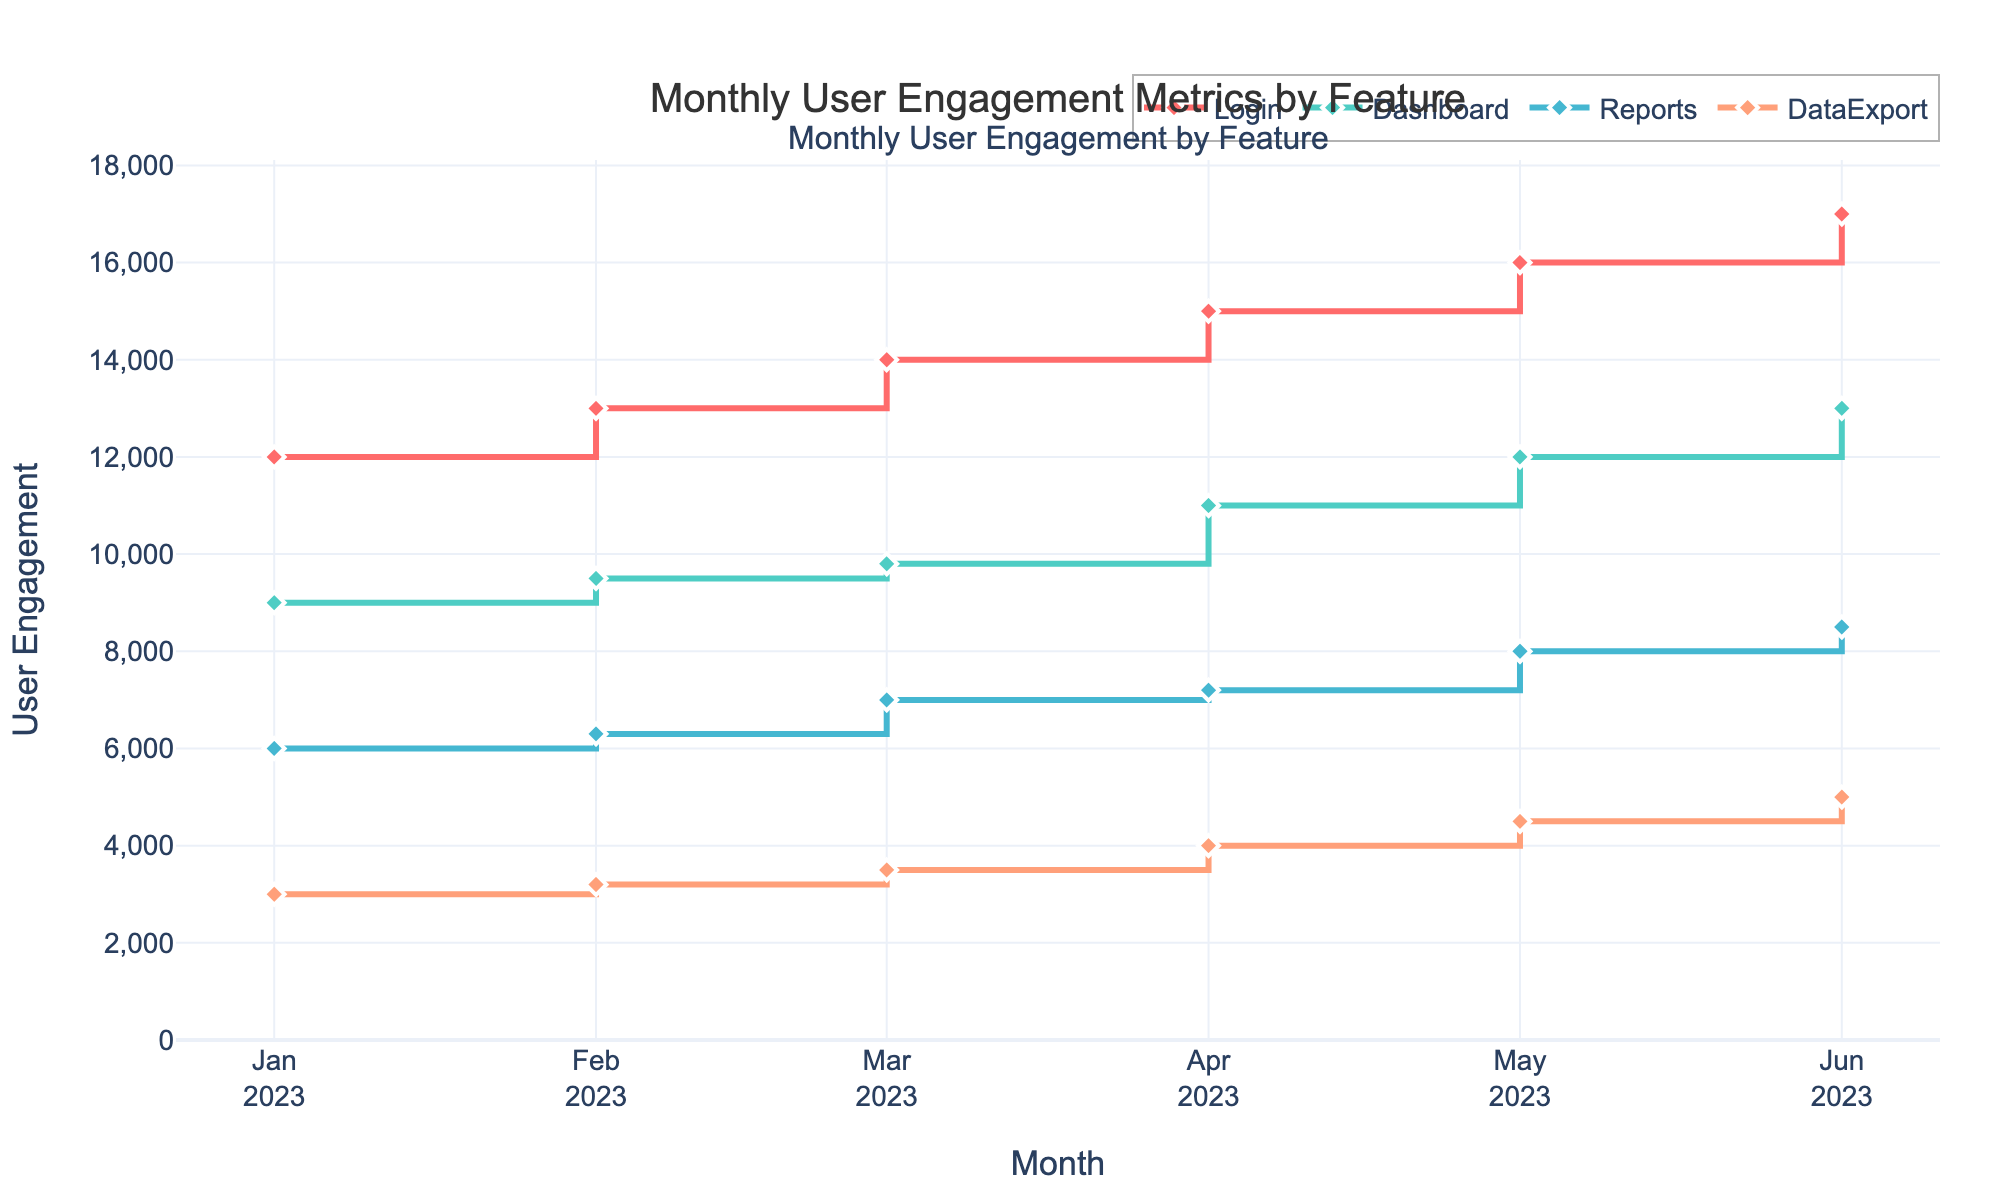What's the title of the figure? The title is prominently displayed above the graph. It summarizes the overall content.
Answer: Monthly User Engagement Metrics by Feature What is the total user engagement for the 'Login' feature in June 2023? Find the point in June 2023 for 'Login' and note the user engagement value.
Answer: 17,000 Which feature shows the lowest user engagement in January 2023? Look at the data points for January 2023 and identify the feature with the smallest value.
Answer: DataExport How did user engagement for the 'Dashboard' feature change from January to June 2023? Compare the data points for the 'Dashboard' feature between January and June 2023. Calculate the difference between the two values.
Answer: Increased by 4,000 What is the average user engagement for the 'Reports' feature from January to June 2023? Sum the monthly user engagements for 'Reports' from January to June and divide by 6 (the number of months). ((6000 + 6300 + 7000 + 7200 + 8000 + 8500) / 6)
Answer: 7167 Which feature shows the most consistent (least variable) user engagement over the months? Evaluate the variance or range of user engagements for each feature over the months. The feature with the smallest difference between the highest and lowest values is the most consistent.
Answer: Dashboard During which month did 'DataExport' see the highest engagement? Locate the highest data point for 'DataExport' across all months.
Answer: June 2023 Compare the user engagement growth rate for 'Login' and 'Dashboard' from January to June 2023. Which feature grew faster? Calculate the growth rate for both features from January to June: 'Login' grew from 12,000 to 17,000 (a 5,000 increase), and 'Dashboard' grew from 9,000 to 13,000 (a 4,000 increase). 'Login' had a higher increase.
Answer: Login What is the trend for the 'Reports' feature from January to June 2023? Observe the data points for 'Reports' and describe whether they are generally increasing, decreasing, or stable.
Answer: Increasing Which month shows the highest combined user engagement for all features? Calculate the sum of user engagements for all features for each month and identify the month with the highest sum. Sum for June 2023: (17,000 + 13,000 + 8,500 + 5,000) = 43,500
Answer: June 2023 